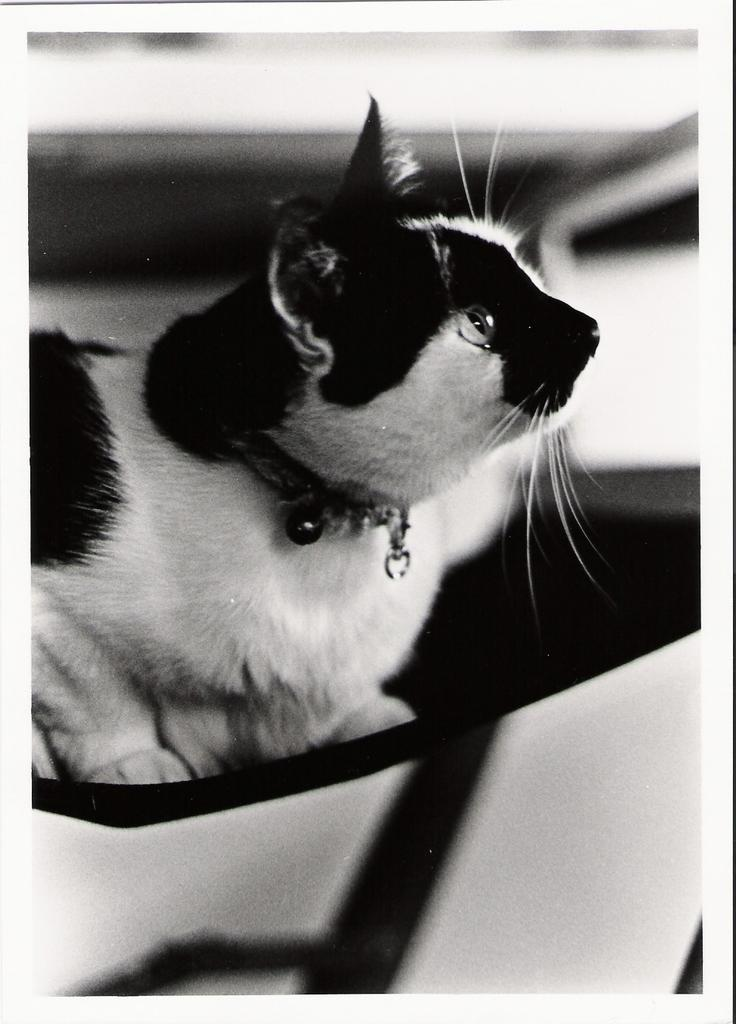What is the color scheme of the image? The image is black and white. What type of animal can be seen in the image? There is a cat in the image. Are there any other objects or elements in the image besides the cat? Yes, there are other objects in the image. What is the relation between the cat and the view in the image? There is no specific view mentioned in the image, and the relation between the cat and any view cannot be determined from the provided facts. 